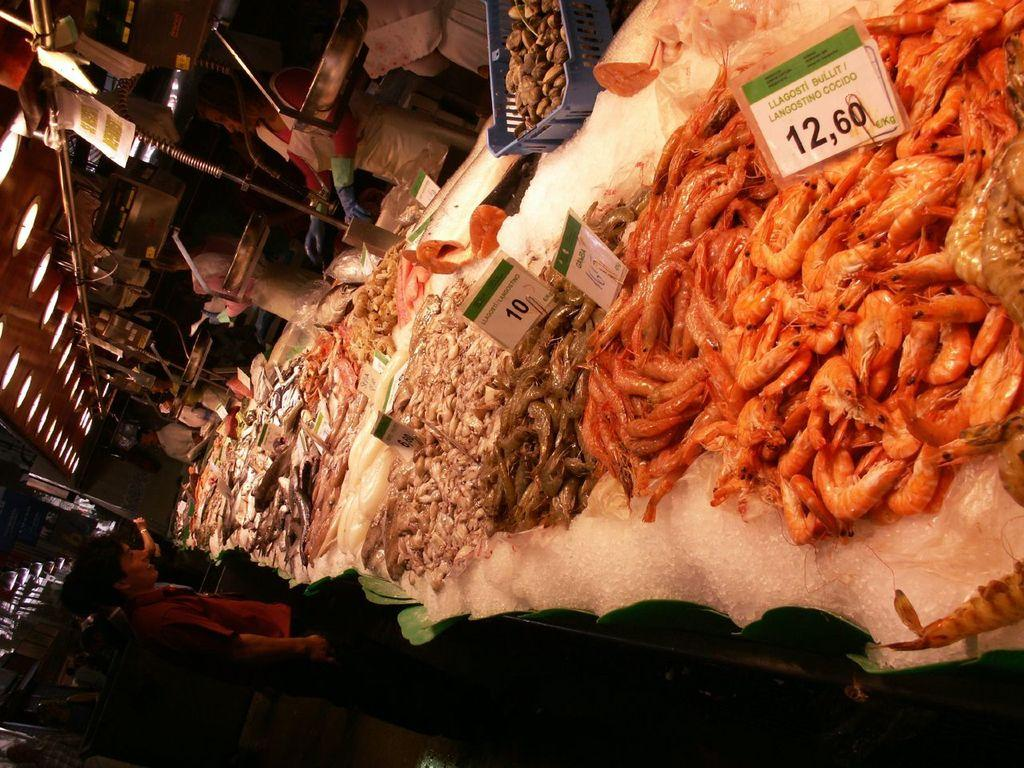What type of food can be seen in the image? There are raw eatables in the image. On what object are the raw eatables placed? The raw eatables are placed on an object. Can you describe the people in the image? There are persons standing on either side of the object. What can be seen in the left corner of the image? There are lights in the left corner of the image. What type of knowledge is being shared by the tomatoes in the image? There are no tomatoes present in the image, and therefore no knowledge can be shared by them. 